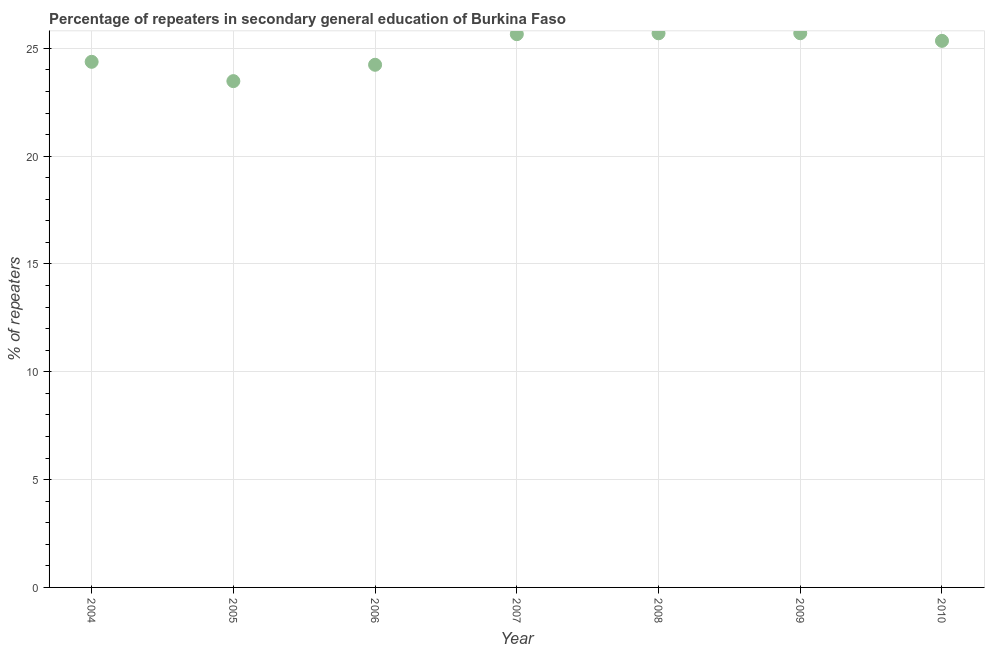What is the percentage of repeaters in 2008?
Offer a terse response. 25.7. Across all years, what is the maximum percentage of repeaters?
Offer a very short reply. 25.7. Across all years, what is the minimum percentage of repeaters?
Your answer should be very brief. 23.48. In which year was the percentage of repeaters maximum?
Offer a terse response. 2009. In which year was the percentage of repeaters minimum?
Give a very brief answer. 2005. What is the sum of the percentage of repeaters?
Make the answer very short. 174.49. What is the difference between the percentage of repeaters in 2006 and 2010?
Provide a succinct answer. -1.11. What is the average percentage of repeaters per year?
Your response must be concise. 24.93. What is the median percentage of repeaters?
Provide a succinct answer. 25.35. In how many years, is the percentage of repeaters greater than 4 %?
Your answer should be compact. 7. What is the ratio of the percentage of repeaters in 2006 to that in 2009?
Give a very brief answer. 0.94. Is the percentage of repeaters in 2005 less than that in 2010?
Offer a terse response. Yes. What is the difference between the highest and the second highest percentage of repeaters?
Provide a short and direct response. 0. What is the difference between the highest and the lowest percentage of repeaters?
Your response must be concise. 2.22. Does the graph contain any zero values?
Ensure brevity in your answer.  No. What is the title of the graph?
Provide a short and direct response. Percentage of repeaters in secondary general education of Burkina Faso. What is the label or title of the Y-axis?
Ensure brevity in your answer.  % of repeaters. What is the % of repeaters in 2004?
Offer a very short reply. 24.37. What is the % of repeaters in 2005?
Your answer should be very brief. 23.48. What is the % of repeaters in 2006?
Your response must be concise. 24.24. What is the % of repeaters in 2007?
Offer a terse response. 25.66. What is the % of repeaters in 2008?
Offer a very short reply. 25.7. What is the % of repeaters in 2009?
Provide a succinct answer. 25.7. What is the % of repeaters in 2010?
Offer a very short reply. 25.35. What is the difference between the % of repeaters in 2004 and 2005?
Give a very brief answer. 0.9. What is the difference between the % of repeaters in 2004 and 2006?
Your response must be concise. 0.14. What is the difference between the % of repeaters in 2004 and 2007?
Make the answer very short. -1.28. What is the difference between the % of repeaters in 2004 and 2008?
Offer a terse response. -1.32. What is the difference between the % of repeaters in 2004 and 2009?
Ensure brevity in your answer.  -1.33. What is the difference between the % of repeaters in 2004 and 2010?
Ensure brevity in your answer.  -0.97. What is the difference between the % of repeaters in 2005 and 2006?
Your answer should be compact. -0.76. What is the difference between the % of repeaters in 2005 and 2007?
Your answer should be very brief. -2.18. What is the difference between the % of repeaters in 2005 and 2008?
Offer a terse response. -2.22. What is the difference between the % of repeaters in 2005 and 2009?
Give a very brief answer. -2.22. What is the difference between the % of repeaters in 2005 and 2010?
Offer a very short reply. -1.87. What is the difference between the % of repeaters in 2006 and 2007?
Provide a short and direct response. -1.42. What is the difference between the % of repeaters in 2006 and 2008?
Give a very brief answer. -1.46. What is the difference between the % of repeaters in 2006 and 2009?
Offer a terse response. -1.46. What is the difference between the % of repeaters in 2006 and 2010?
Make the answer very short. -1.11. What is the difference between the % of repeaters in 2007 and 2008?
Your answer should be compact. -0.04. What is the difference between the % of repeaters in 2007 and 2009?
Offer a very short reply. -0.04. What is the difference between the % of repeaters in 2007 and 2010?
Give a very brief answer. 0.31. What is the difference between the % of repeaters in 2008 and 2009?
Offer a terse response. -0. What is the difference between the % of repeaters in 2008 and 2010?
Your response must be concise. 0.35. What is the difference between the % of repeaters in 2009 and 2010?
Provide a succinct answer. 0.35. What is the ratio of the % of repeaters in 2004 to that in 2005?
Give a very brief answer. 1.04. What is the ratio of the % of repeaters in 2004 to that in 2006?
Ensure brevity in your answer.  1.01. What is the ratio of the % of repeaters in 2004 to that in 2007?
Your answer should be very brief. 0.95. What is the ratio of the % of repeaters in 2004 to that in 2008?
Provide a succinct answer. 0.95. What is the ratio of the % of repeaters in 2004 to that in 2009?
Your answer should be compact. 0.95. What is the ratio of the % of repeaters in 2005 to that in 2007?
Keep it short and to the point. 0.92. What is the ratio of the % of repeaters in 2005 to that in 2008?
Make the answer very short. 0.91. What is the ratio of the % of repeaters in 2005 to that in 2009?
Keep it short and to the point. 0.91. What is the ratio of the % of repeaters in 2005 to that in 2010?
Keep it short and to the point. 0.93. What is the ratio of the % of repeaters in 2006 to that in 2007?
Your response must be concise. 0.94. What is the ratio of the % of repeaters in 2006 to that in 2008?
Provide a short and direct response. 0.94. What is the ratio of the % of repeaters in 2006 to that in 2009?
Keep it short and to the point. 0.94. What is the ratio of the % of repeaters in 2006 to that in 2010?
Your response must be concise. 0.96. What is the ratio of the % of repeaters in 2007 to that in 2008?
Provide a succinct answer. 1. What is the ratio of the % of repeaters in 2007 to that in 2009?
Your answer should be compact. 1. What is the ratio of the % of repeaters in 2008 to that in 2010?
Offer a terse response. 1.01. What is the ratio of the % of repeaters in 2009 to that in 2010?
Make the answer very short. 1.01. 